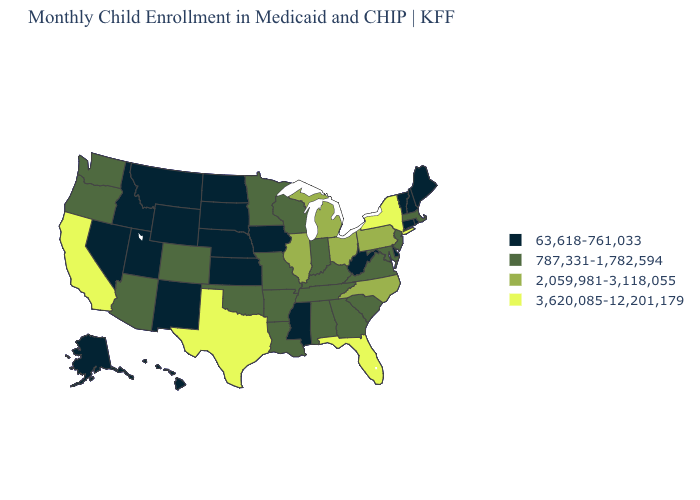Name the states that have a value in the range 3,620,085-12,201,179?
Keep it brief. California, Florida, New York, Texas. What is the value of Idaho?
Give a very brief answer. 63,618-761,033. Which states hav the highest value in the West?
Be succinct. California. Name the states that have a value in the range 63,618-761,033?
Be succinct. Alaska, Connecticut, Delaware, Hawaii, Idaho, Iowa, Kansas, Maine, Mississippi, Montana, Nebraska, Nevada, New Hampshire, New Mexico, North Dakota, Rhode Island, South Dakota, Utah, Vermont, West Virginia, Wyoming. Name the states that have a value in the range 3,620,085-12,201,179?
Concise answer only. California, Florida, New York, Texas. Name the states that have a value in the range 3,620,085-12,201,179?
Write a very short answer. California, Florida, New York, Texas. Does Kentucky have the same value as New Jersey?
Answer briefly. Yes. What is the value of South Dakota?
Write a very short answer. 63,618-761,033. What is the value of New Jersey?
Answer briefly. 787,331-1,782,594. What is the lowest value in states that border Minnesota?
Short answer required. 63,618-761,033. Is the legend a continuous bar?
Keep it brief. No. What is the value of Pennsylvania?
Write a very short answer. 2,059,981-3,118,055. What is the lowest value in states that border Florida?
Write a very short answer. 787,331-1,782,594. Name the states that have a value in the range 63,618-761,033?
Keep it brief. Alaska, Connecticut, Delaware, Hawaii, Idaho, Iowa, Kansas, Maine, Mississippi, Montana, Nebraska, Nevada, New Hampshire, New Mexico, North Dakota, Rhode Island, South Dakota, Utah, Vermont, West Virginia, Wyoming. Name the states that have a value in the range 2,059,981-3,118,055?
Quick response, please. Illinois, Michigan, North Carolina, Ohio, Pennsylvania. 